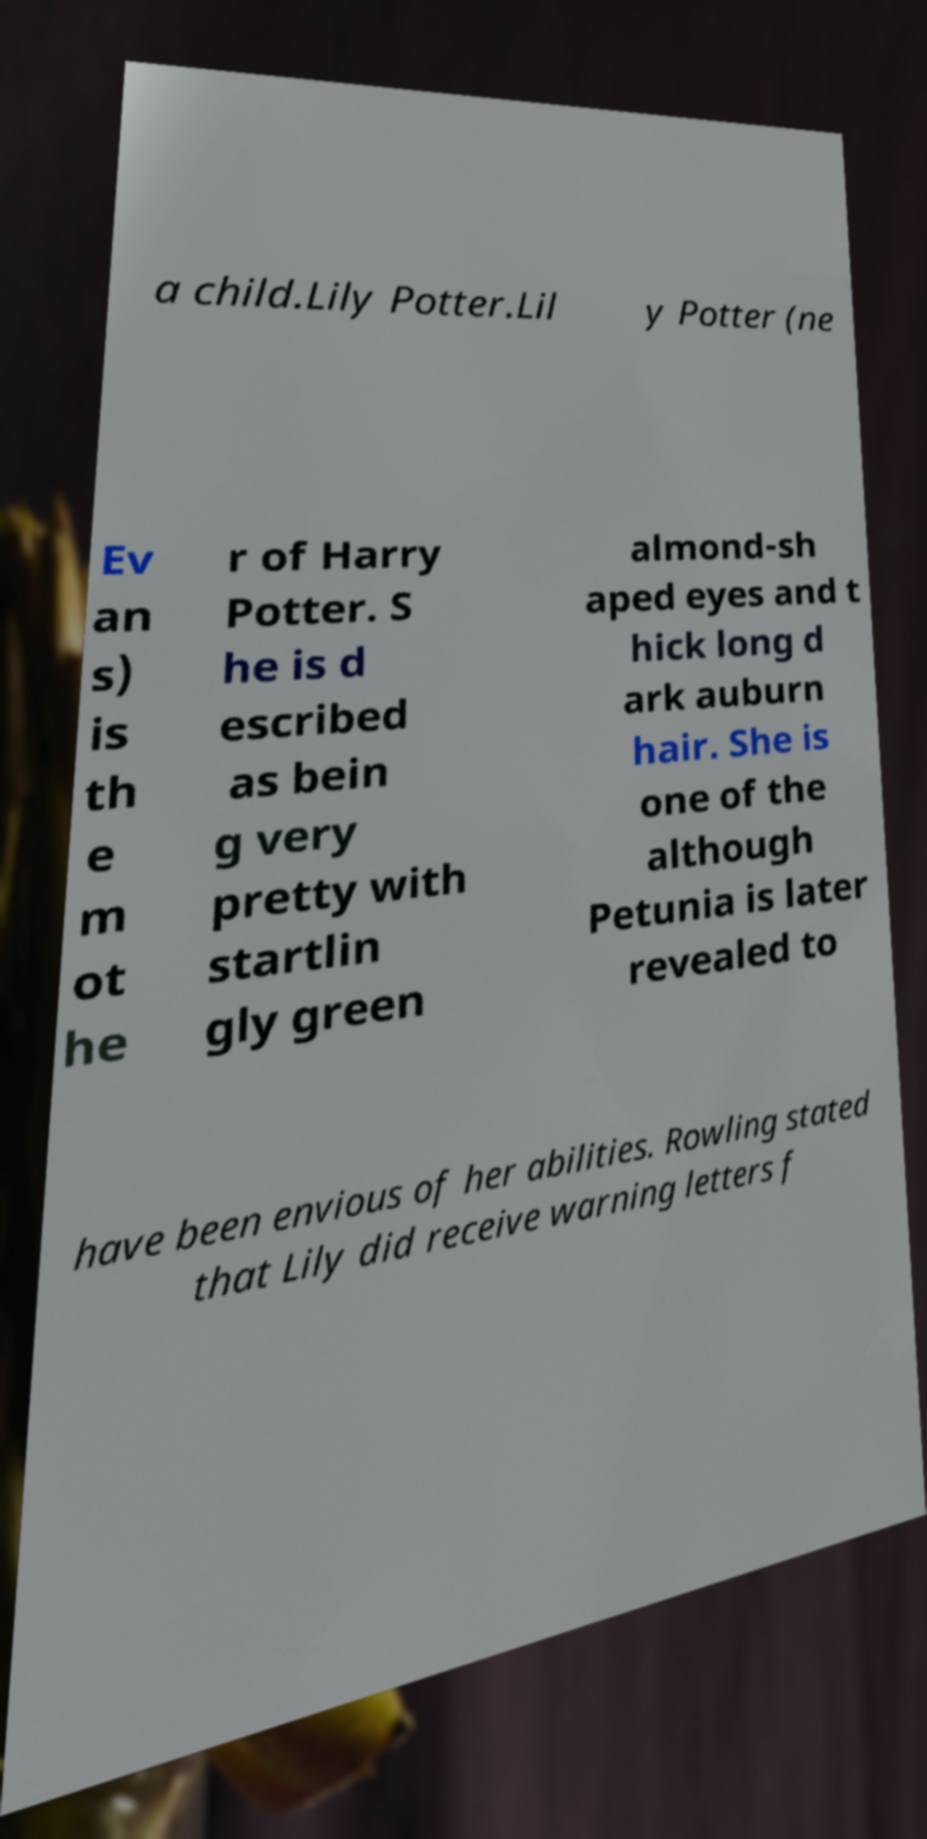Can you accurately transcribe the text from the provided image for me? a child.Lily Potter.Lil y Potter (ne Ev an s) is th e m ot he r of Harry Potter. S he is d escribed as bein g very pretty with startlin gly green almond-sh aped eyes and t hick long d ark auburn hair. She is one of the although Petunia is later revealed to have been envious of her abilities. Rowling stated that Lily did receive warning letters f 